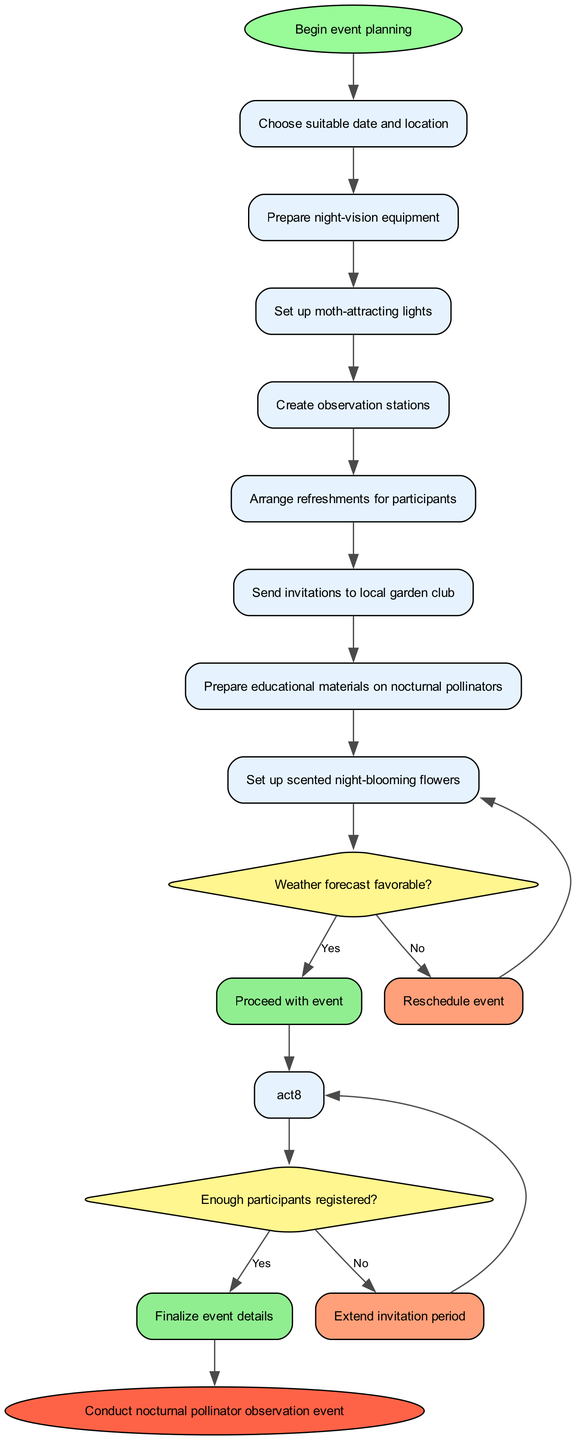What is the first activity in the workflow? The diagram begins with the "Begin event planning" node, which directs to the first activity. The first activity listed is "Choose suitable date and location."
Answer: Choose suitable date and location How many activities are there in total? The diagram lists eight activities in total, starting from "Choose suitable date and location" to "Set up scented night-blooming flowers."
Answer: Eight What happens if the weather forecast is not favorable? According to the decision node in the diagram, if the weather forecast is not favorable, the workflow leads to "Reschedule event."
Answer: Reschedule event What is the condition of the second decision point in the diagram? The second decision point asks, "Enough participants registered?" which evaluates participation for the event.
Answer: Enough participants registered? How does the workflow proceed after confirming enough participants are registered? After confirming sufficient participants, the workflow indicates to "Finalize event details," leading directly to the event's completion.
Answer: Finalize event details What color represents the decision nodes in the diagram? The decision nodes are filled with a yellow color as indicated by the hex code #FFF68F in the diagram format.
Answer: Yellow If the event is rescheduled, which activity will follow? If the decision to reschedule occurs, the workflow loops back to the last activity before the decision point, which is "Set up moth-attracting lights."
Answer: Set up moth-attracting lights How many decision points are present in the diagram? The diagram comprises two major decision points regarding weather and participant registration.
Answer: Two What is the final outcome of the workflow? The end node of the workflow indicates the purpose of the activities leading up to it, which is to "Conduct nocturnal pollinator observation event."
Answer: Conduct nocturnal pollinator observation event 